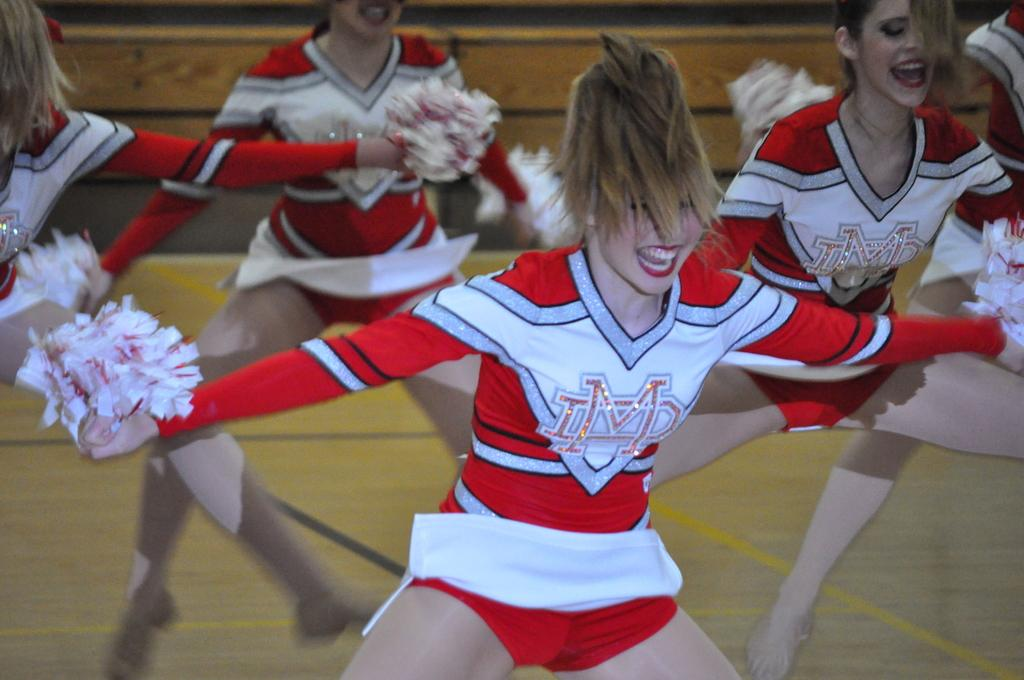<image>
Share a concise interpretation of the image provided. A girl is in a cheer costume with the letters LMD on the front. 